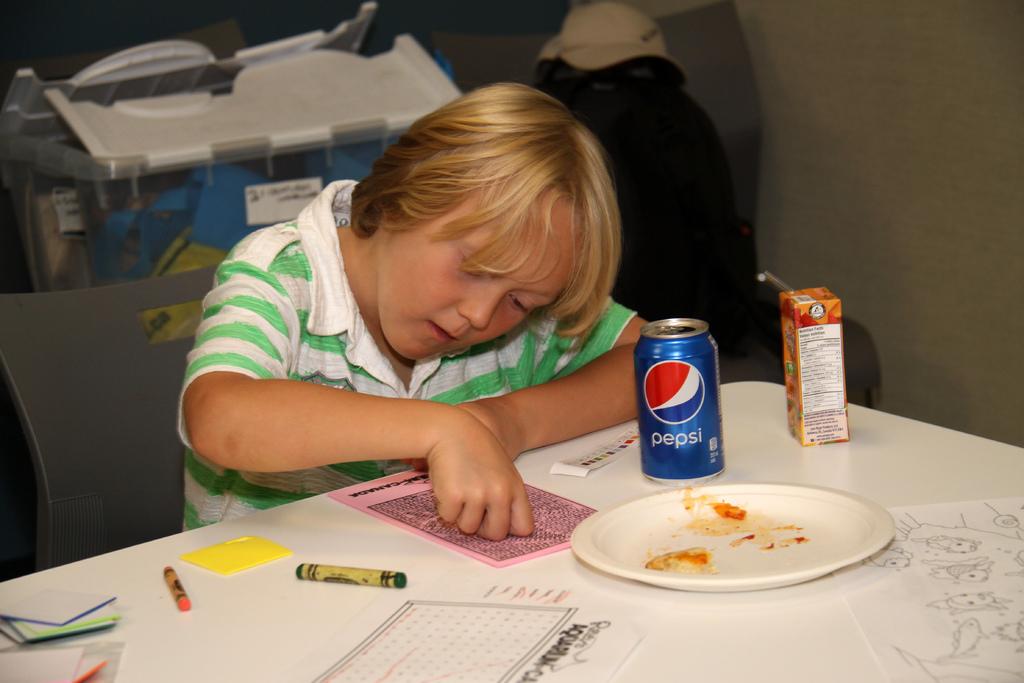What brand of soda is the blue can?
Your answer should be very brief. Pepsi. 